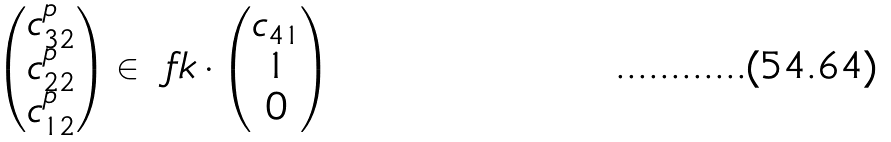<formula> <loc_0><loc_0><loc_500><loc_500>\begin{pmatrix} c _ { 3 2 } ^ { p } \\ c _ { 2 2 } ^ { p } \\ c _ { 1 2 } ^ { p } \end{pmatrix} \in \ f k \cdot \begin{pmatrix} c _ { 4 1 } \\ 1 \\ 0 \end{pmatrix}</formula> 